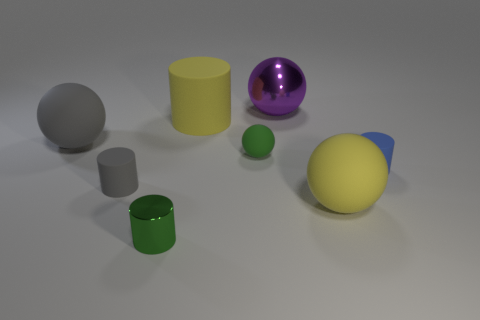Add 2 purple blocks. How many objects exist? 10 Subtract 0 red balls. How many objects are left? 8 Subtract all small brown shiny things. Subtract all small rubber things. How many objects are left? 5 Add 6 large purple metal things. How many large purple metal things are left? 7 Add 2 purple rubber blocks. How many purple rubber blocks exist? 2 